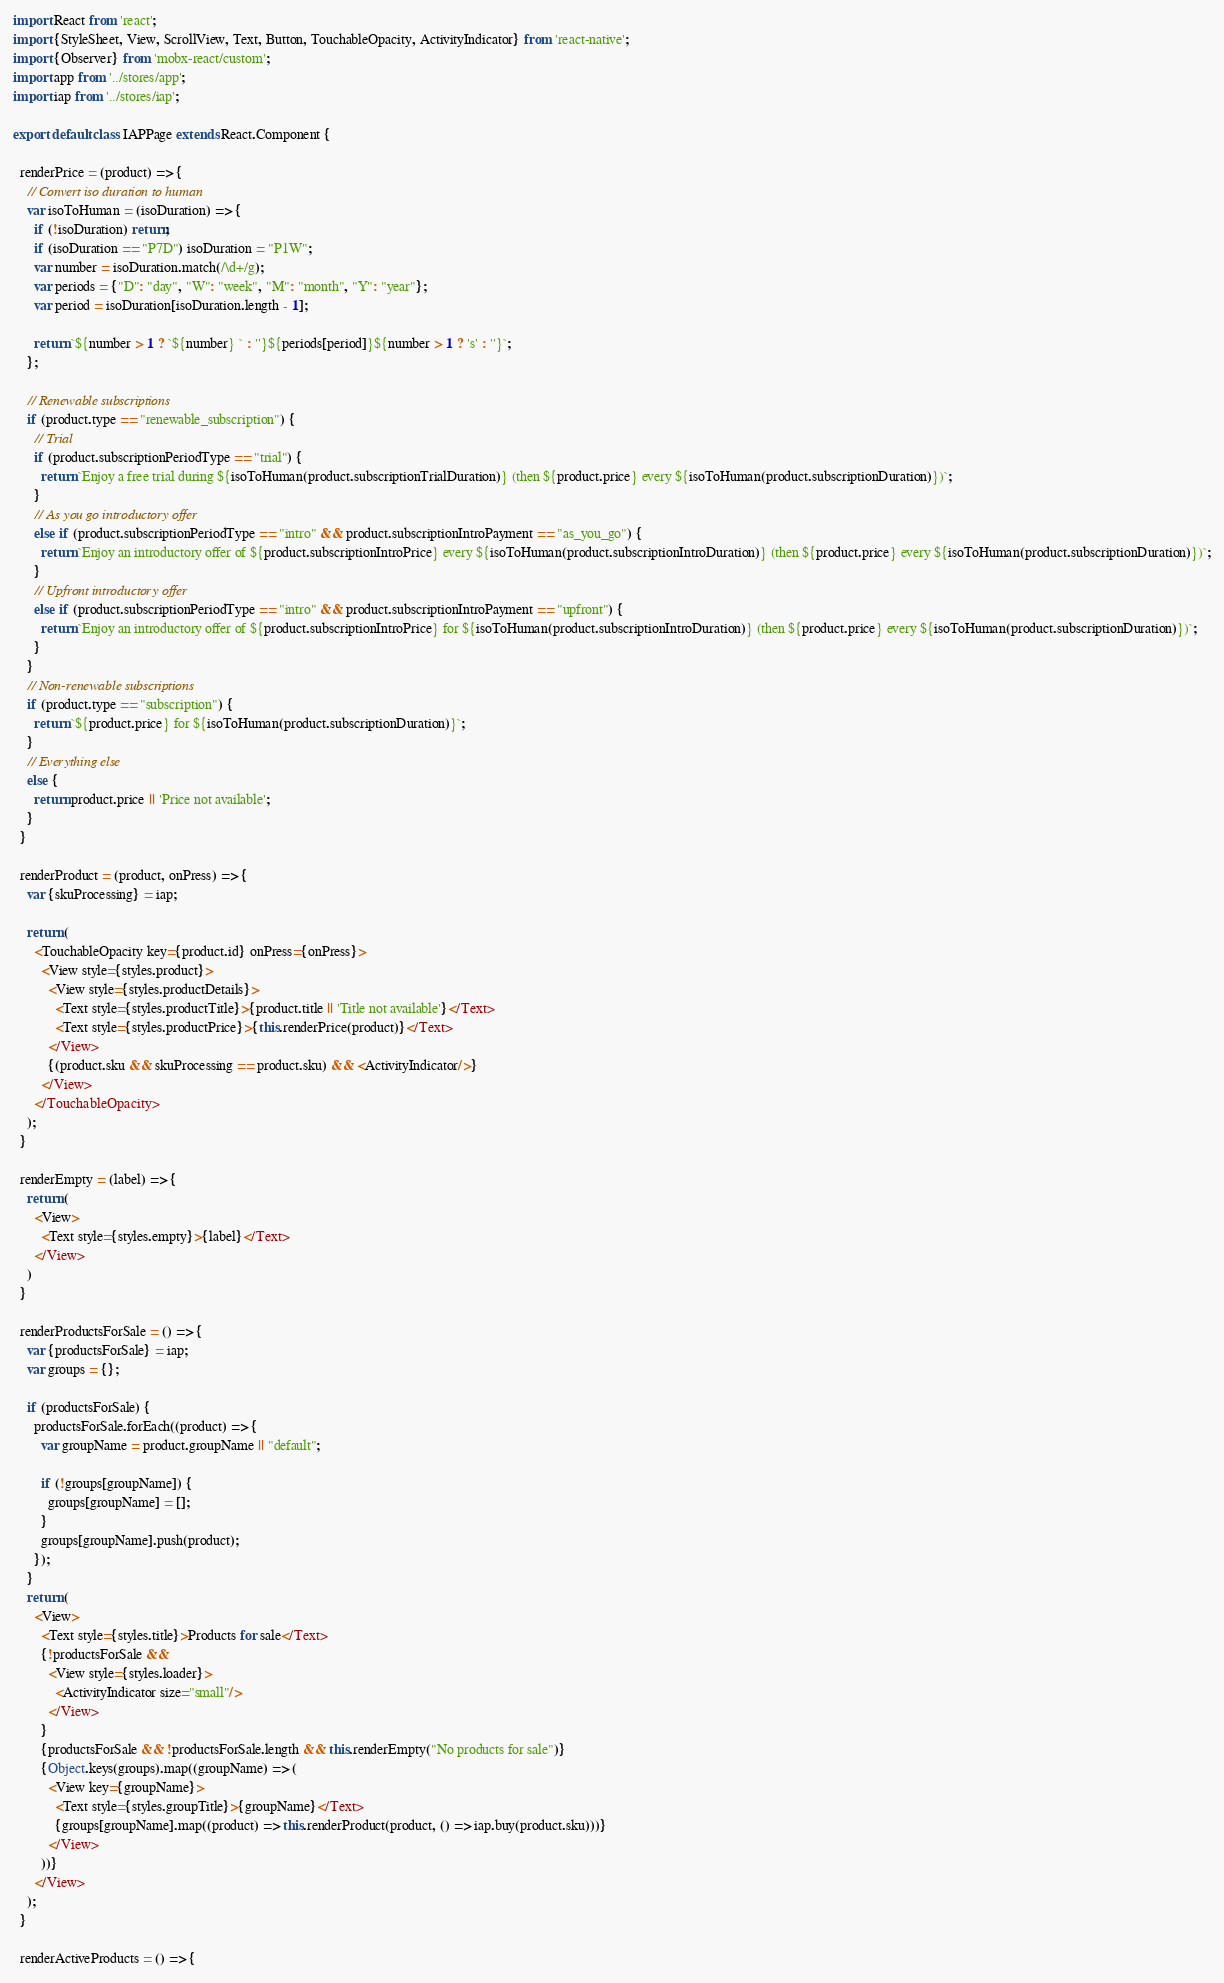Convert code to text. <code><loc_0><loc_0><loc_500><loc_500><_JavaScript_>import React from 'react';
import {StyleSheet, View, ScrollView, Text, Button, TouchableOpacity, ActivityIndicator} from 'react-native';
import {Observer} from 'mobx-react/custom';
import app from '../stores/app';
import iap from '../stores/iap';

export default class IAPPage extends React.Component {

  renderPrice = (product) => {
    // Convert iso duration to human
    var isoToHuman = (isoDuration) => {
      if (!isoDuration) return;
      if (isoDuration == "P7D") isoDuration = "P1W";
      var number = isoDuration.match(/\d+/g);
      var periods = {"D": "day", "W": "week", "M": "month", "Y": "year"};
      var period = isoDuration[isoDuration.length - 1];

      return `${number > 1 ? `${number} ` : ''}${periods[period]}${number > 1 ? 's' : ''}`;
    };

    // Renewable subscriptions
    if (product.type == "renewable_subscription") {
      // Trial
      if (product.subscriptionPeriodType == "trial") {
        return `Enjoy a free trial during ${isoToHuman(product.subscriptionTrialDuration)} (then ${product.price} every ${isoToHuman(product.subscriptionDuration)})`;
      }
      // As you go introductory offer
      else if (product.subscriptionPeriodType == "intro" && product.subscriptionIntroPayment == "as_you_go") {
        return `Enjoy an introductory offer of ${product.subscriptionIntroPrice} every ${isoToHuman(product.subscriptionIntroDuration)} (then ${product.price} every ${isoToHuman(product.subscriptionDuration)})`;
      }
      // Upfront introductory offer
      else if (product.subscriptionPeriodType == "intro" && product.subscriptionIntroPayment == "upfront") {
        return `Enjoy an introductory offer of ${product.subscriptionIntroPrice} for ${isoToHuman(product.subscriptionIntroDuration)} (then ${product.price} every ${isoToHuman(product.subscriptionDuration)})`;
      }
    }
    // Non-renewable subscriptions
    if (product.type == "subscription") {
      return `${product.price} for ${isoToHuman(product.subscriptionDuration)}`;
    }
    // Everything else
    else {
      return product.price || 'Price not available';
    }
  }

  renderProduct = (product, onPress) => {
    var {skuProcessing} = iap;

    return (
      <TouchableOpacity key={product.id} onPress={onPress}>
        <View style={styles.product}>
          <View style={styles.productDetails}>
            <Text style={styles.productTitle}>{product.title || 'Title not available'}</Text>
            <Text style={styles.productPrice}>{this.renderPrice(product)}</Text>
          </View>
          {(product.sku && skuProcessing == product.sku) && <ActivityIndicator/>}
        </View>
      </TouchableOpacity>
    );
  }

  renderEmpty = (label) => {
    return (
      <View>
        <Text style={styles.empty}>{label}</Text>
      </View>
    )
  }

  renderProductsForSale = () => {
    var {productsForSale} = iap;
    var groups = {};

    if (productsForSale) {
      productsForSale.forEach((product) => {
        var groupName = product.groupName || "default";

        if (!groups[groupName]) {
          groups[groupName] = [];
        }
        groups[groupName].push(product);
      });
    }
    return (
      <View>
        <Text style={styles.title}>Products for sale</Text>
        {!productsForSale &&
          <View style={styles.loader}>
            <ActivityIndicator size="small"/>
          </View>
        }
        {productsForSale && !productsForSale.length && this.renderEmpty("No products for sale")}
        {Object.keys(groups).map((groupName) => (
          <View key={groupName}>
            <Text style={styles.groupTitle}>{groupName}</Text>
            {groups[groupName].map((product) => this.renderProduct(product, () => iap.buy(product.sku)))}
          </View>
        ))}
      </View>
    );
  }

  renderActiveProducts = () => {</code> 